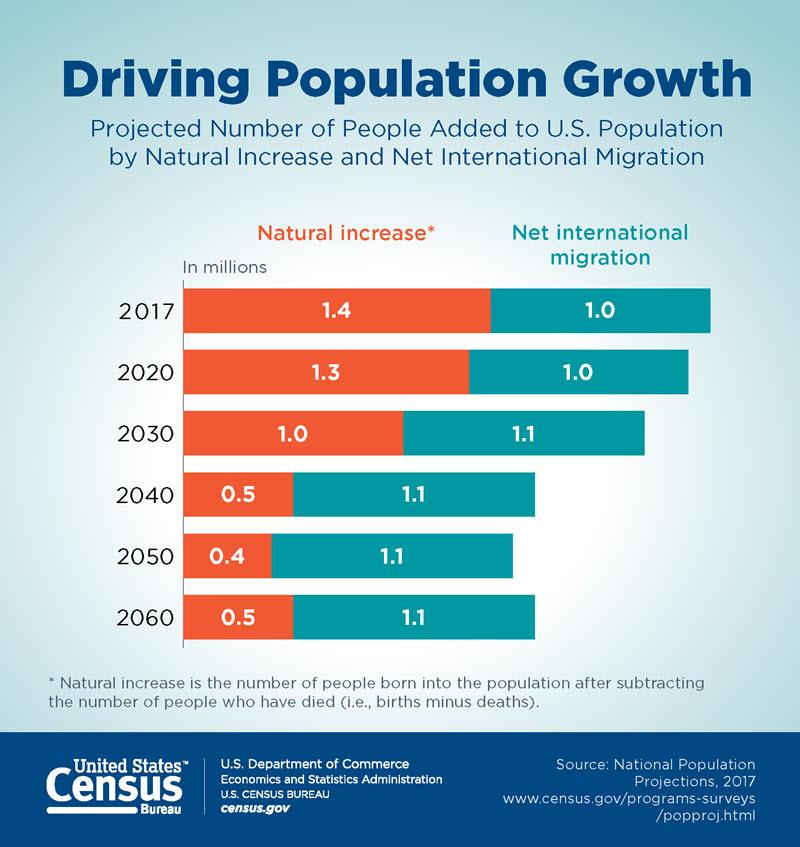Point out several critical features in this image. In recent years, net international migration has been approximately 1.1. From the year 2016 to 2017, the net international migration rate increased by 2.8%. For how many years did net international migration equal 1.0? The net international migration in 2020 and 2030, taken together, is estimated to be 2.1 million. 